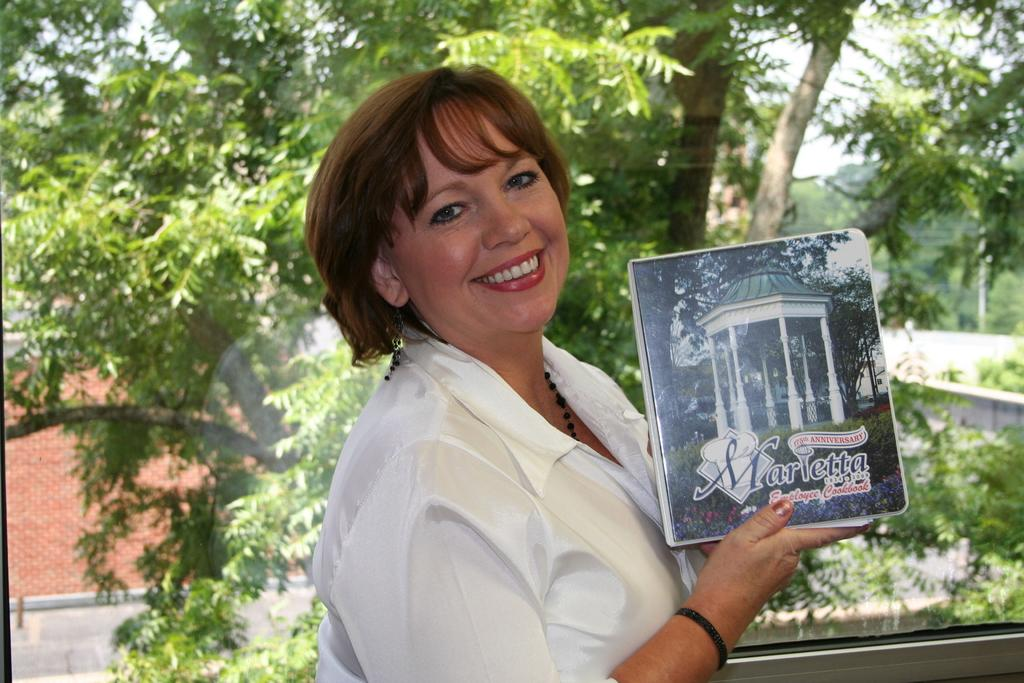Who is present in the image? There is a woman in the image. What is the woman doing in the image? The woman is standing and holding a book in her hand. What is the woman wearing in the image? The woman is wearing a white color shirt. How is the woman feeling in the image? The woman has a smile on her face, indicating that she is happy or content. What can be seen in the background of the image? There are trees and a house visible in the image. What type of comfort is the woman providing to the committee in the image? There is no committee present in the image, and the woman is not providing any comfort. 